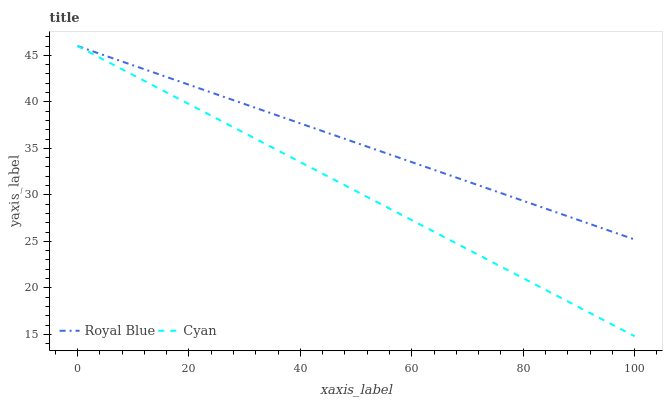Does Cyan have the minimum area under the curve?
Answer yes or no. Yes. Does Royal Blue have the maximum area under the curve?
Answer yes or no. Yes. Does Cyan have the maximum area under the curve?
Answer yes or no. No. Is Royal Blue the smoothest?
Answer yes or no. Yes. Is Cyan the roughest?
Answer yes or no. Yes. Is Cyan the smoothest?
Answer yes or no. No. 